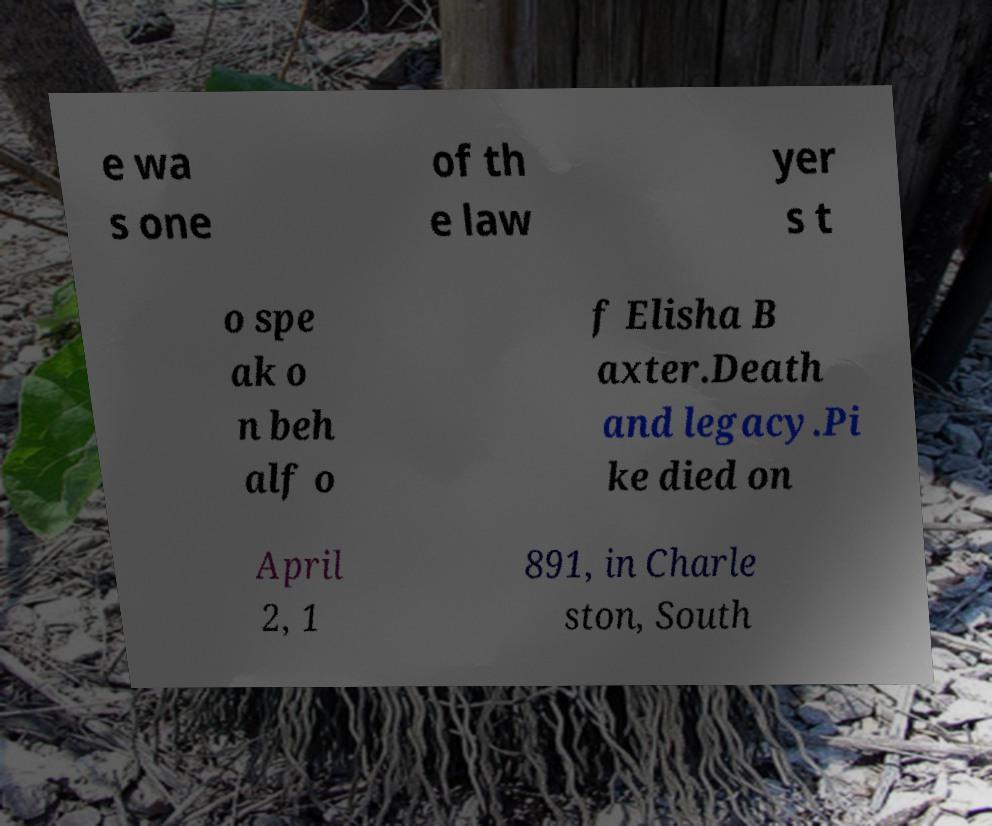I need the written content from this picture converted into text. Can you do that? e wa s one of th e law yer s t o spe ak o n beh alf o f Elisha B axter.Death and legacy.Pi ke died on April 2, 1 891, in Charle ston, South 